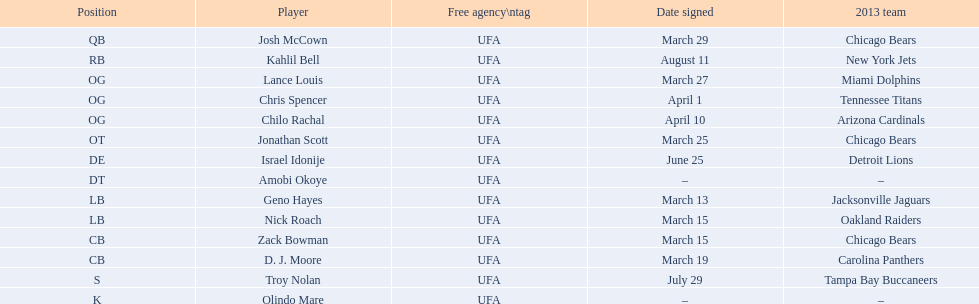Geno hayes and nick roach both played which position? LB. 